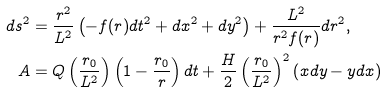Convert formula to latex. <formula><loc_0><loc_0><loc_500><loc_500>d s ^ { 2 } & = \frac { r ^ { 2 } } { L ^ { 2 } } \left ( - f ( r ) d t ^ { 2 } + d x ^ { 2 } + d y ^ { 2 } \right ) + \frac { L ^ { 2 } } { r ^ { 2 } f ( r ) } d r ^ { 2 } , \\ A & = Q \left ( \frac { r _ { 0 } } { L ^ { 2 } } \right ) \left ( 1 - \frac { r _ { 0 } } { r } \right ) d t + \frac { H } { 2 } \left ( \frac { r _ { 0 } } { L ^ { 2 } } \right ) ^ { 2 } \left ( x d y - y d x \right )</formula> 